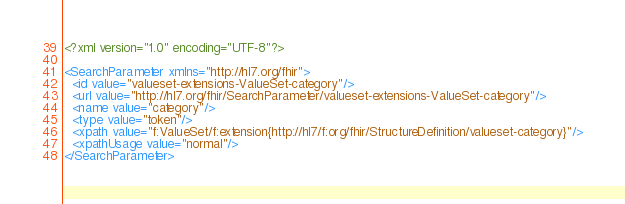<code> <loc_0><loc_0><loc_500><loc_500><_XML_><?xml version="1.0" encoding="UTF-8"?>

<SearchParameter xmlns="http://hl7.org/fhir">
  <id value="valueset-extensions-ValueSet-category"/>
  <url value="http://hl7.org/fhir/SearchParameter/valueset-extensions-ValueSet-category"/>
  <name value="category"/>
  <type value="token"/>
  <xpath value="f:ValueSet/f:extension{http://hl7/f:org/fhir/StructureDefinition/valueset-category}"/>
  <xpathUsage value="normal"/>
</SearchParameter></code> 